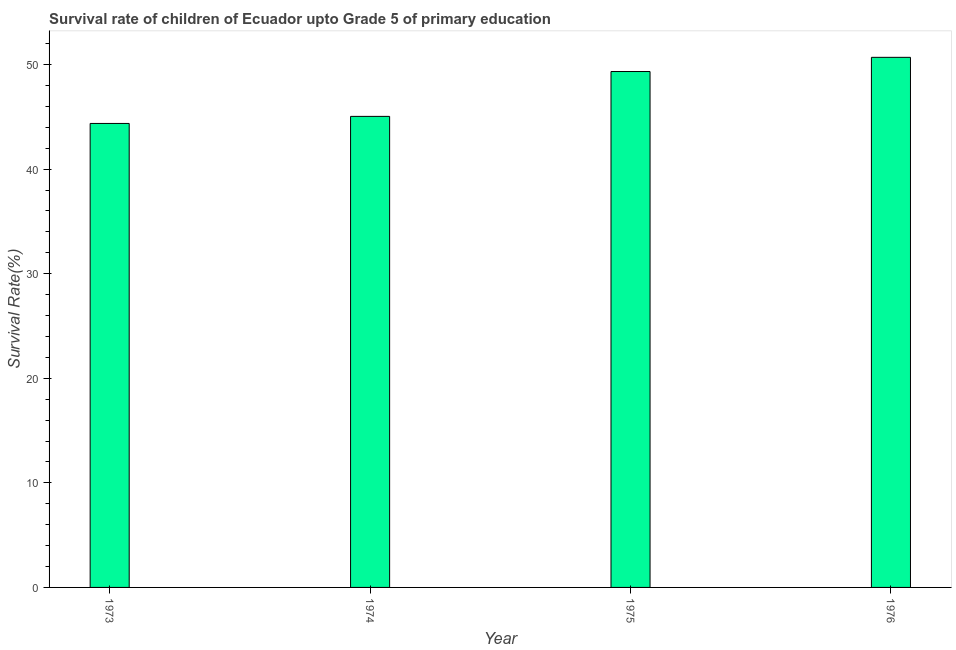Does the graph contain any zero values?
Ensure brevity in your answer.  No. Does the graph contain grids?
Offer a terse response. No. What is the title of the graph?
Offer a very short reply. Survival rate of children of Ecuador upto Grade 5 of primary education. What is the label or title of the Y-axis?
Your response must be concise. Survival Rate(%). What is the survival rate in 1974?
Offer a very short reply. 45.04. Across all years, what is the maximum survival rate?
Ensure brevity in your answer.  50.69. Across all years, what is the minimum survival rate?
Provide a short and direct response. 44.37. In which year was the survival rate maximum?
Your answer should be compact. 1976. In which year was the survival rate minimum?
Make the answer very short. 1973. What is the sum of the survival rate?
Provide a short and direct response. 189.43. What is the difference between the survival rate in 1974 and 1976?
Give a very brief answer. -5.65. What is the average survival rate per year?
Offer a very short reply. 47.36. What is the median survival rate?
Provide a succinct answer. 47.19. What is the ratio of the survival rate in 1974 to that in 1976?
Offer a terse response. 0.89. What is the difference between the highest and the second highest survival rate?
Give a very brief answer. 1.36. What is the difference between the highest and the lowest survival rate?
Offer a terse response. 6.32. In how many years, is the survival rate greater than the average survival rate taken over all years?
Make the answer very short. 2. Are all the bars in the graph horizontal?
Your response must be concise. No. Are the values on the major ticks of Y-axis written in scientific E-notation?
Offer a very short reply. No. What is the Survival Rate(%) of 1973?
Your response must be concise. 44.37. What is the Survival Rate(%) of 1974?
Ensure brevity in your answer.  45.04. What is the Survival Rate(%) of 1975?
Offer a terse response. 49.33. What is the Survival Rate(%) of 1976?
Your answer should be very brief. 50.69. What is the difference between the Survival Rate(%) in 1973 and 1974?
Offer a terse response. -0.68. What is the difference between the Survival Rate(%) in 1973 and 1975?
Offer a very short reply. -4.97. What is the difference between the Survival Rate(%) in 1973 and 1976?
Give a very brief answer. -6.32. What is the difference between the Survival Rate(%) in 1974 and 1975?
Make the answer very short. -4.29. What is the difference between the Survival Rate(%) in 1974 and 1976?
Give a very brief answer. -5.65. What is the difference between the Survival Rate(%) in 1975 and 1976?
Your response must be concise. -1.36. What is the ratio of the Survival Rate(%) in 1973 to that in 1974?
Keep it short and to the point. 0.98. What is the ratio of the Survival Rate(%) in 1973 to that in 1975?
Provide a short and direct response. 0.9. What is the ratio of the Survival Rate(%) in 1974 to that in 1975?
Make the answer very short. 0.91. What is the ratio of the Survival Rate(%) in 1974 to that in 1976?
Provide a succinct answer. 0.89. 